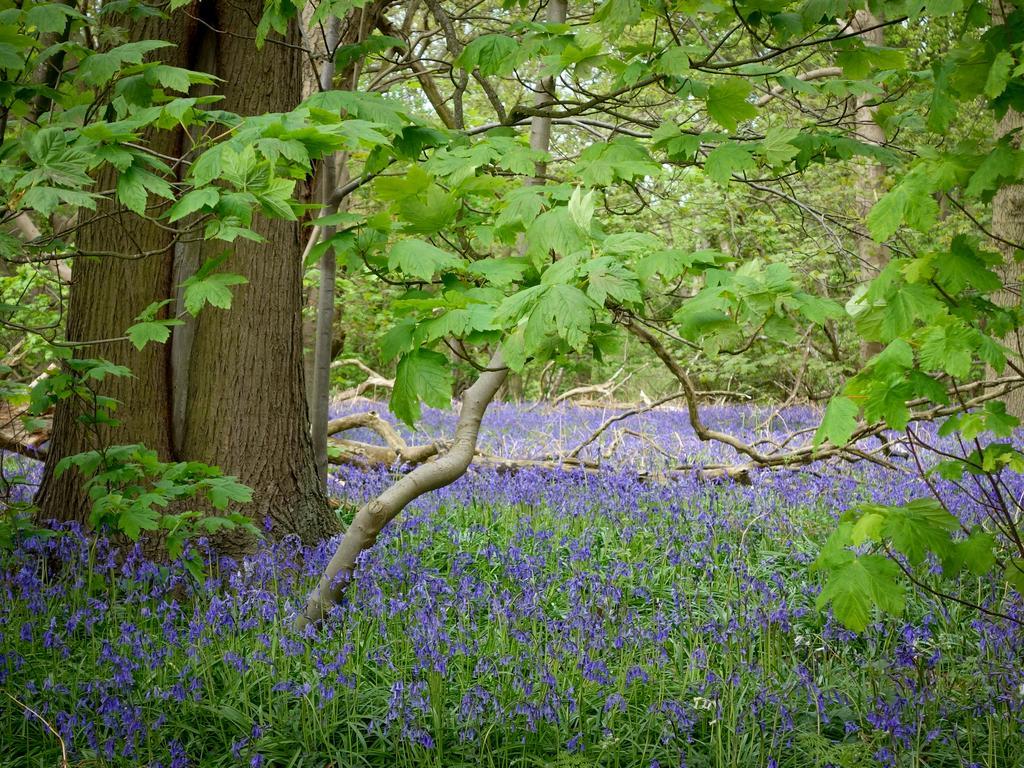In one or two sentences, can you explain what this image depicts? In this image we can see plants, flowers, and trees. 